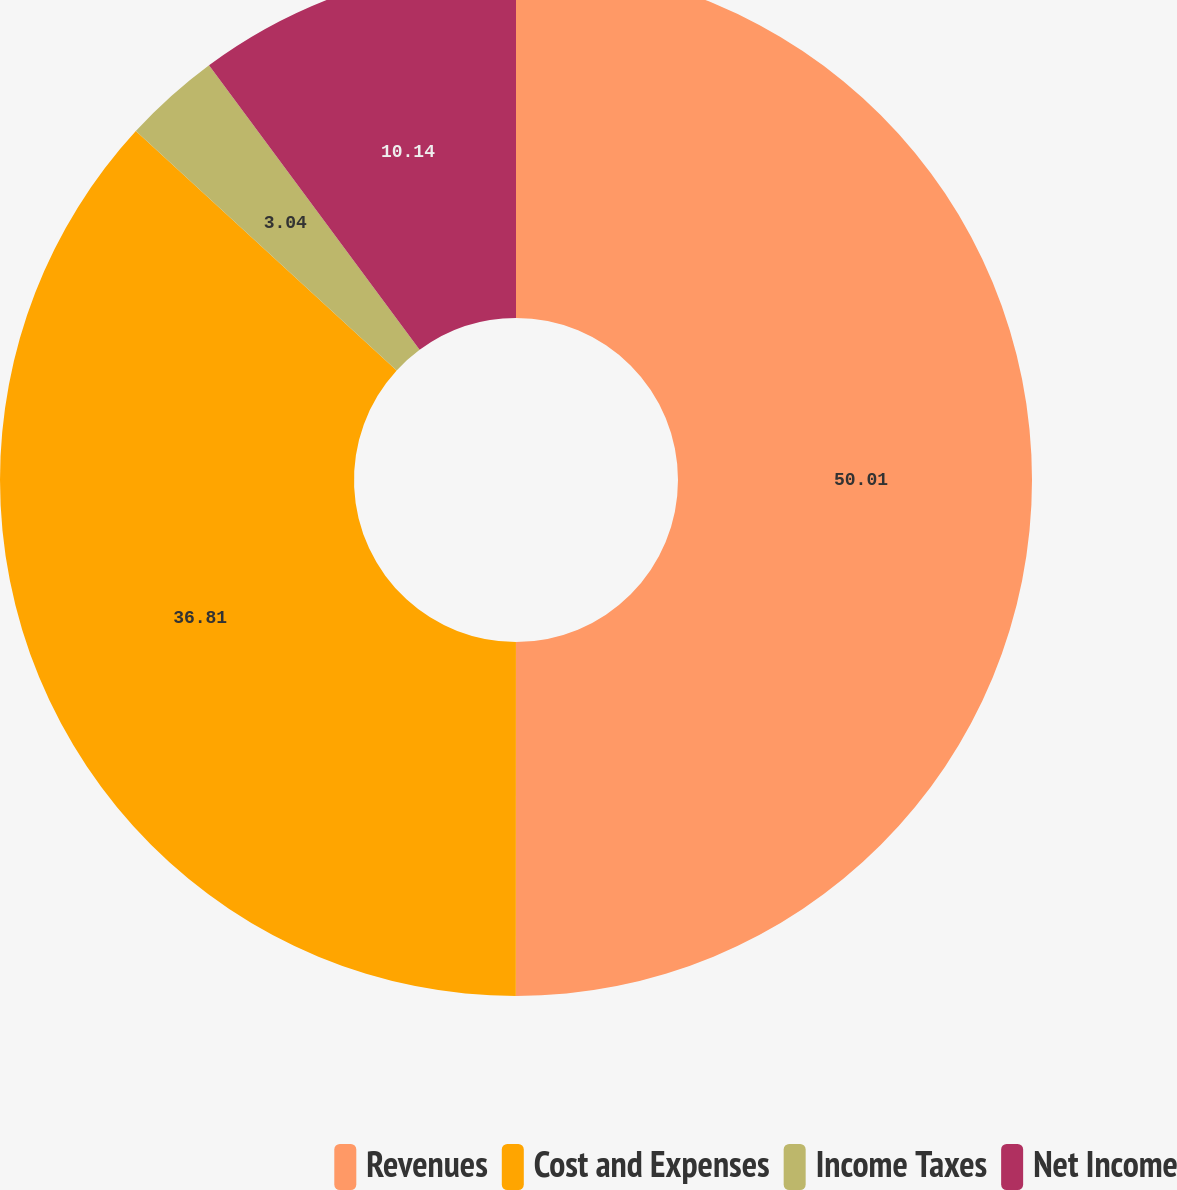Convert chart to OTSL. <chart><loc_0><loc_0><loc_500><loc_500><pie_chart><fcel>Revenues<fcel>Cost and Expenses<fcel>Income Taxes<fcel>Net Income<nl><fcel>50.0%<fcel>36.81%<fcel>3.04%<fcel>10.14%<nl></chart> 